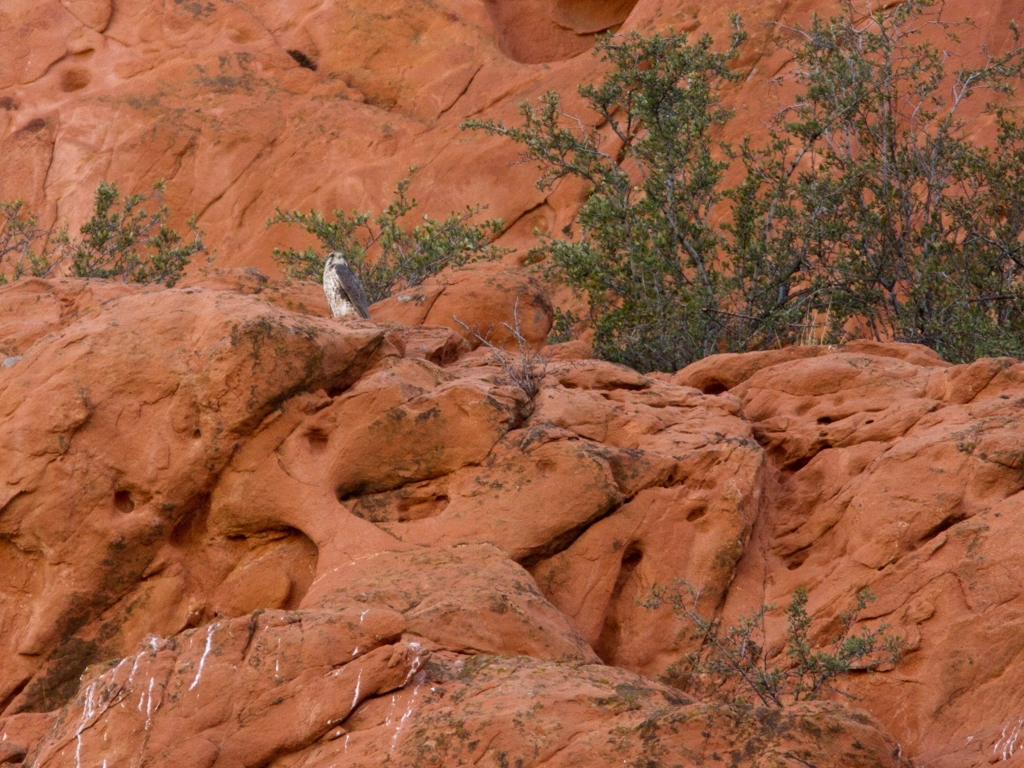Can you tell me about any wildlife that might live in this environment? In landscapes like the one pictured, you are likely to find a variety of wildlife that has adapted to arid conditions. This includes reptiles such as lizards and snakes, small mammals like rodents, and a range of bird species, some of which may be seen perched or nesting on the rocky ledges. 